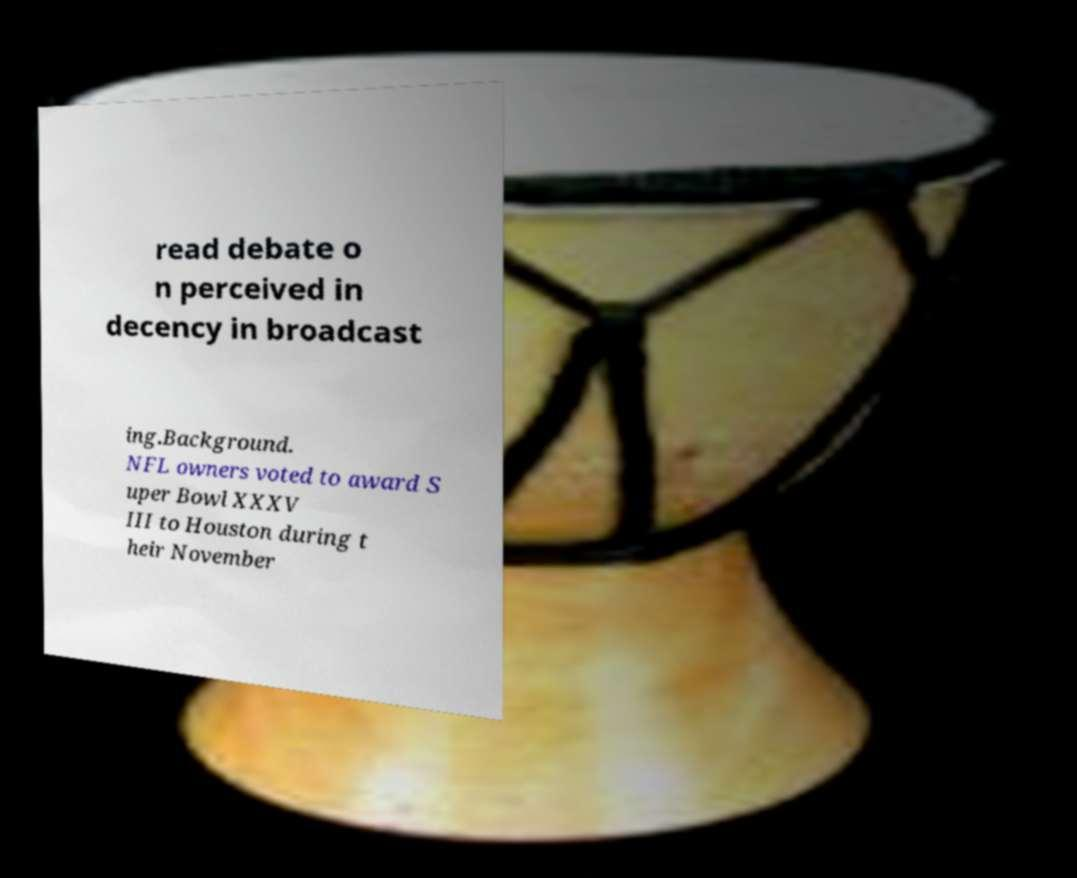Please read and relay the text visible in this image. What does it say? read debate o n perceived in decency in broadcast ing.Background. NFL owners voted to award S uper Bowl XXXV III to Houston during t heir November 